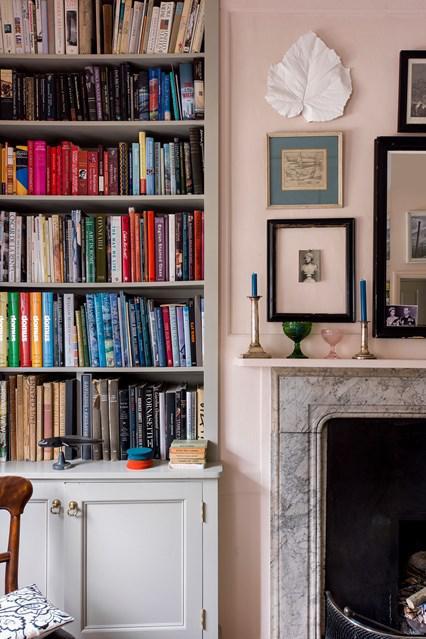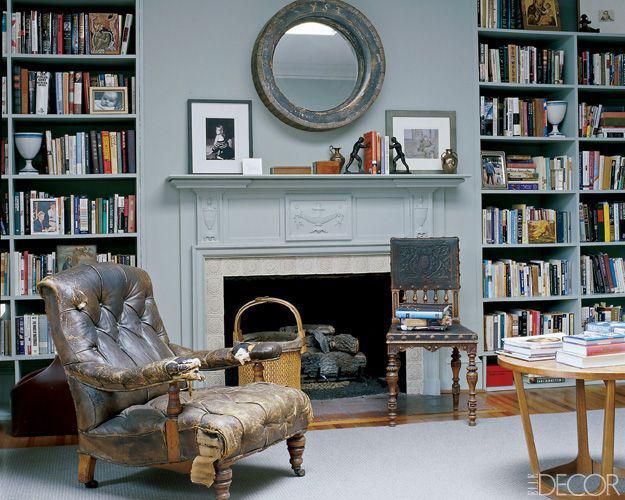The first image is the image on the left, the second image is the image on the right. For the images displayed, is the sentence "A room includes a beige sofa near a fireplace flanked by white built-in bookshelves, with something rectangular over the fireplace." factually correct? Answer yes or no. No. The first image is the image on the left, the second image is the image on the right. Evaluate the accuracy of this statement regarding the images: "In one image, floor to ceiling bookshelves are on both sides of a central fireplace with decor filling the space above.". Is it true? Answer yes or no. Yes. 